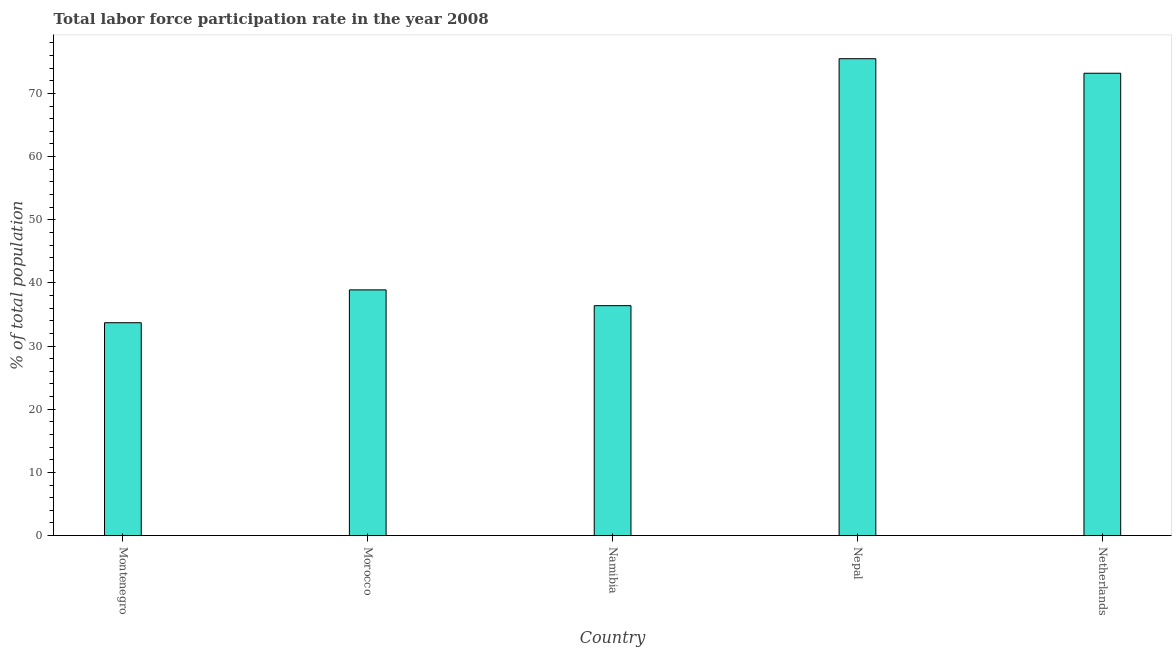Does the graph contain grids?
Provide a short and direct response. No. What is the title of the graph?
Make the answer very short. Total labor force participation rate in the year 2008. What is the label or title of the Y-axis?
Provide a short and direct response. % of total population. What is the total labor force participation rate in Morocco?
Your answer should be compact. 38.9. Across all countries, what is the maximum total labor force participation rate?
Give a very brief answer. 75.5. Across all countries, what is the minimum total labor force participation rate?
Provide a short and direct response. 33.7. In which country was the total labor force participation rate maximum?
Give a very brief answer. Nepal. In which country was the total labor force participation rate minimum?
Offer a terse response. Montenegro. What is the sum of the total labor force participation rate?
Your answer should be compact. 257.7. What is the difference between the total labor force participation rate in Montenegro and Namibia?
Your answer should be very brief. -2.7. What is the average total labor force participation rate per country?
Give a very brief answer. 51.54. What is the median total labor force participation rate?
Your answer should be very brief. 38.9. What is the ratio of the total labor force participation rate in Namibia to that in Nepal?
Provide a succinct answer. 0.48. Is the total labor force participation rate in Montenegro less than that in Nepal?
Offer a very short reply. Yes. What is the difference between the highest and the second highest total labor force participation rate?
Your answer should be compact. 2.3. What is the difference between the highest and the lowest total labor force participation rate?
Ensure brevity in your answer.  41.8. How many bars are there?
Keep it short and to the point. 5. Are all the bars in the graph horizontal?
Make the answer very short. No. What is the difference between two consecutive major ticks on the Y-axis?
Your response must be concise. 10. What is the % of total population of Montenegro?
Keep it short and to the point. 33.7. What is the % of total population in Morocco?
Offer a terse response. 38.9. What is the % of total population in Namibia?
Your answer should be compact. 36.4. What is the % of total population in Nepal?
Your answer should be very brief. 75.5. What is the % of total population of Netherlands?
Offer a very short reply. 73.2. What is the difference between the % of total population in Montenegro and Nepal?
Offer a terse response. -41.8. What is the difference between the % of total population in Montenegro and Netherlands?
Provide a short and direct response. -39.5. What is the difference between the % of total population in Morocco and Nepal?
Provide a short and direct response. -36.6. What is the difference between the % of total population in Morocco and Netherlands?
Offer a terse response. -34.3. What is the difference between the % of total population in Namibia and Nepal?
Give a very brief answer. -39.1. What is the difference between the % of total population in Namibia and Netherlands?
Provide a short and direct response. -36.8. What is the difference between the % of total population in Nepal and Netherlands?
Offer a very short reply. 2.3. What is the ratio of the % of total population in Montenegro to that in Morocco?
Keep it short and to the point. 0.87. What is the ratio of the % of total population in Montenegro to that in Namibia?
Make the answer very short. 0.93. What is the ratio of the % of total population in Montenegro to that in Nepal?
Offer a terse response. 0.45. What is the ratio of the % of total population in Montenegro to that in Netherlands?
Offer a very short reply. 0.46. What is the ratio of the % of total population in Morocco to that in Namibia?
Make the answer very short. 1.07. What is the ratio of the % of total population in Morocco to that in Nepal?
Your response must be concise. 0.52. What is the ratio of the % of total population in Morocco to that in Netherlands?
Ensure brevity in your answer.  0.53. What is the ratio of the % of total population in Namibia to that in Nepal?
Give a very brief answer. 0.48. What is the ratio of the % of total population in Namibia to that in Netherlands?
Keep it short and to the point. 0.5. What is the ratio of the % of total population in Nepal to that in Netherlands?
Keep it short and to the point. 1.03. 